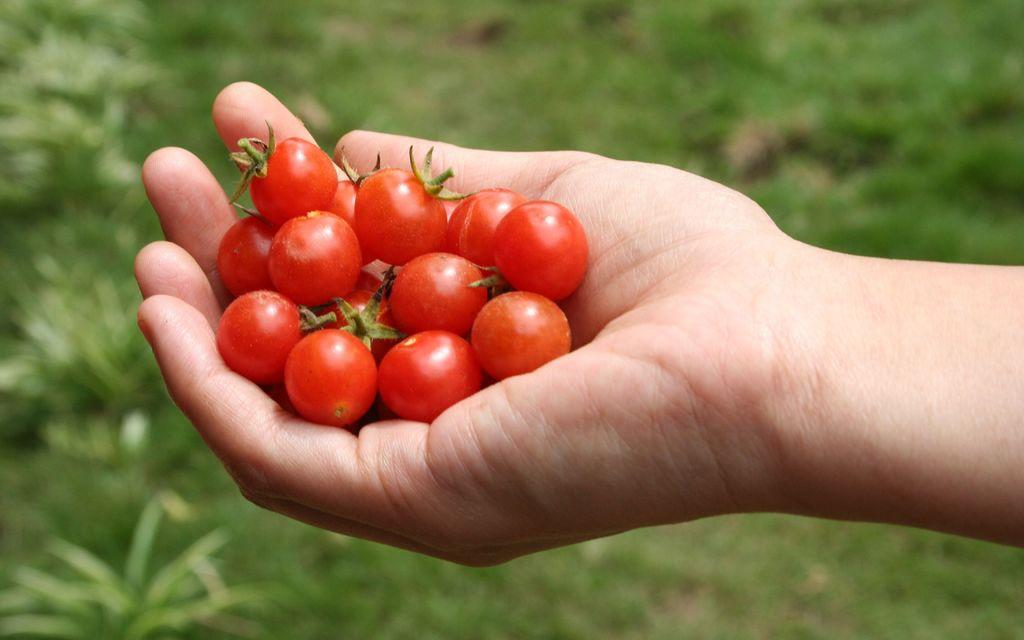What is the hand in the image holding? The hand is holding tomatoes. What type of surface is visible at the bottom of the image? There is grass visible at the bottom of the image. What type of vegetation can be seen at the bottom of the image? There are plants visible at the bottom of the image. How many teeth can be seen in the image? A: There are no teeth visible in the image; it features a hand holding tomatoes and a grassy background. 